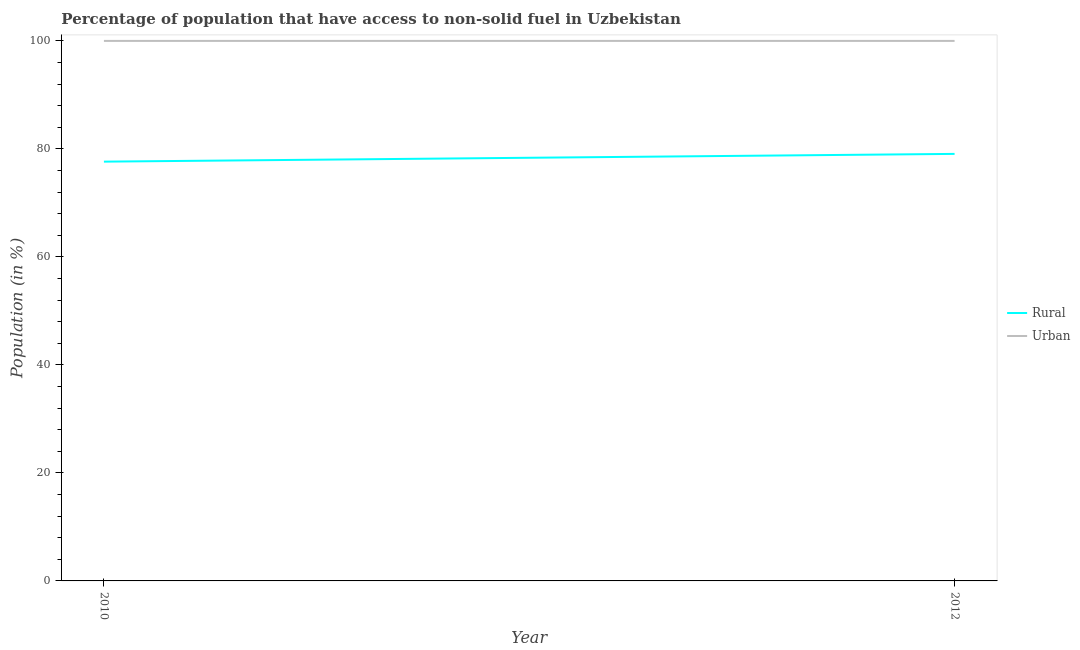Does the line corresponding to urban population intersect with the line corresponding to rural population?
Make the answer very short. No. What is the urban population in 2012?
Your response must be concise. 100. Across all years, what is the maximum urban population?
Your response must be concise. 100. Across all years, what is the minimum urban population?
Provide a short and direct response. 100. What is the total urban population in the graph?
Keep it short and to the point. 200. What is the difference between the rural population in 2010 and that in 2012?
Keep it short and to the point. -1.44. What is the difference between the urban population in 2012 and the rural population in 2010?
Your answer should be very brief. 22.36. What is the average rural population per year?
Give a very brief answer. 78.36. In the year 2010, what is the difference between the urban population and rural population?
Offer a very short reply. 22.36. What is the ratio of the rural population in 2010 to that in 2012?
Offer a very short reply. 0.98. In how many years, is the urban population greater than the average urban population taken over all years?
Ensure brevity in your answer.  0. Is the urban population strictly greater than the rural population over the years?
Provide a short and direct response. Yes. How many lines are there?
Keep it short and to the point. 2. How many years are there in the graph?
Offer a very short reply. 2. What is the difference between two consecutive major ticks on the Y-axis?
Ensure brevity in your answer.  20. Are the values on the major ticks of Y-axis written in scientific E-notation?
Make the answer very short. No. Does the graph contain any zero values?
Your response must be concise. No. How many legend labels are there?
Give a very brief answer. 2. What is the title of the graph?
Offer a terse response. Percentage of population that have access to non-solid fuel in Uzbekistan. What is the Population (in %) in Rural in 2010?
Your response must be concise. 77.64. What is the Population (in %) in Rural in 2012?
Your response must be concise. 79.08. Across all years, what is the maximum Population (in %) of Rural?
Offer a very short reply. 79.08. Across all years, what is the maximum Population (in %) of Urban?
Ensure brevity in your answer.  100. Across all years, what is the minimum Population (in %) in Rural?
Your answer should be compact. 77.64. Across all years, what is the minimum Population (in %) in Urban?
Your answer should be compact. 100. What is the total Population (in %) of Rural in the graph?
Your response must be concise. 156.72. What is the total Population (in %) of Urban in the graph?
Your response must be concise. 200. What is the difference between the Population (in %) of Rural in 2010 and that in 2012?
Give a very brief answer. -1.44. What is the difference between the Population (in %) in Rural in 2010 and the Population (in %) in Urban in 2012?
Offer a terse response. -22.36. What is the average Population (in %) of Rural per year?
Make the answer very short. 78.36. In the year 2010, what is the difference between the Population (in %) in Rural and Population (in %) in Urban?
Provide a succinct answer. -22.36. In the year 2012, what is the difference between the Population (in %) of Rural and Population (in %) of Urban?
Give a very brief answer. -20.92. What is the ratio of the Population (in %) in Rural in 2010 to that in 2012?
Give a very brief answer. 0.98. What is the ratio of the Population (in %) in Urban in 2010 to that in 2012?
Keep it short and to the point. 1. What is the difference between the highest and the second highest Population (in %) of Rural?
Your answer should be compact. 1.44. What is the difference between the highest and the lowest Population (in %) of Rural?
Your answer should be very brief. 1.44. 